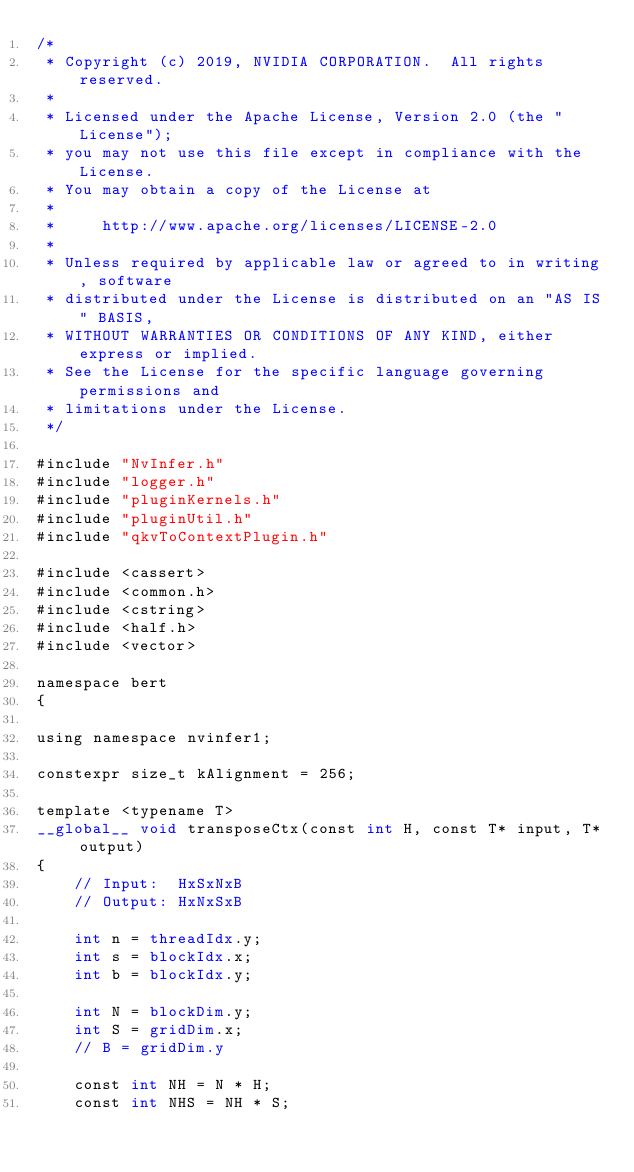<code> <loc_0><loc_0><loc_500><loc_500><_Cuda_>/*
 * Copyright (c) 2019, NVIDIA CORPORATION.  All rights reserved.
 *
 * Licensed under the Apache License, Version 2.0 (the "License");
 * you may not use this file except in compliance with the License.
 * You may obtain a copy of the License at
 *
 *     http://www.apache.org/licenses/LICENSE-2.0
 *
 * Unless required by applicable law or agreed to in writing, software
 * distributed under the License is distributed on an "AS IS" BASIS,
 * WITHOUT WARRANTIES OR CONDITIONS OF ANY KIND, either express or implied.
 * See the License for the specific language governing permissions and
 * limitations under the License.
 */

#include "NvInfer.h"
#include "logger.h"
#include "pluginKernels.h"
#include "pluginUtil.h"
#include "qkvToContextPlugin.h"

#include <cassert>
#include <common.h>
#include <cstring>
#include <half.h>
#include <vector>

namespace bert
{

using namespace nvinfer1;

constexpr size_t kAlignment = 256;

template <typename T>
__global__ void transposeCtx(const int H, const T* input, T* output)
{
    // Input:  HxSxNxB
    // Output: HxNxSxB

    int n = threadIdx.y;
    int s = blockIdx.x;
    int b = blockIdx.y;

    int N = blockDim.y;
    int S = gridDim.x;
    // B = gridDim.y

    const int NH = N * H;
    const int NHS = NH * S;</code> 